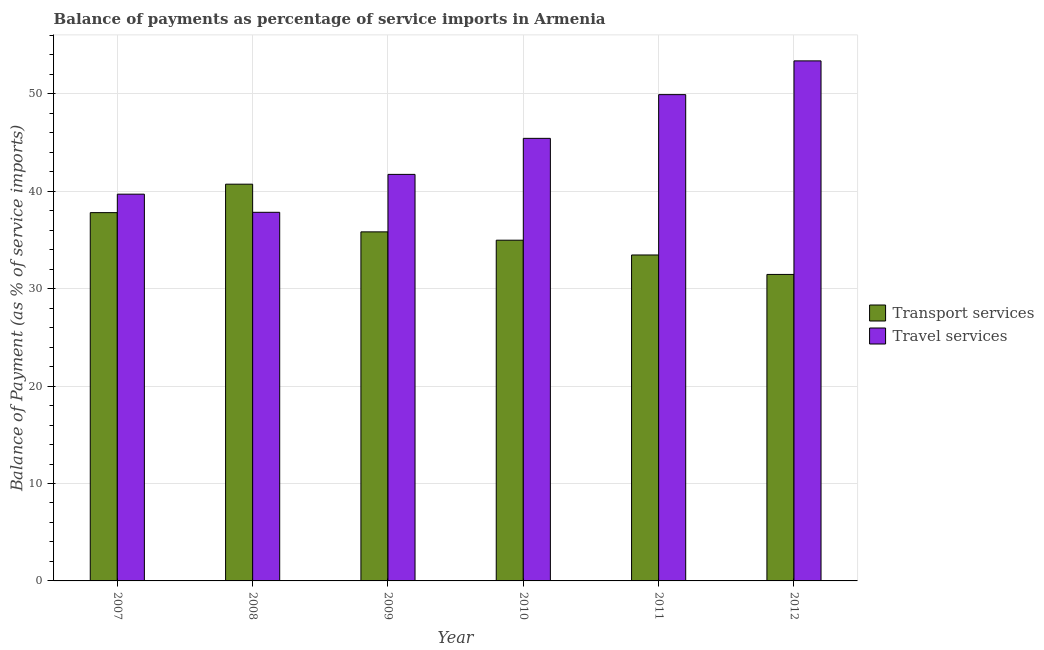How many different coloured bars are there?
Your answer should be very brief. 2. How many groups of bars are there?
Offer a very short reply. 6. How many bars are there on the 3rd tick from the left?
Offer a very short reply. 2. How many bars are there on the 2nd tick from the right?
Give a very brief answer. 2. What is the label of the 5th group of bars from the left?
Keep it short and to the point. 2011. In how many cases, is the number of bars for a given year not equal to the number of legend labels?
Your response must be concise. 0. What is the balance of payments of travel services in 2010?
Offer a very short reply. 45.43. Across all years, what is the maximum balance of payments of transport services?
Offer a terse response. 40.72. Across all years, what is the minimum balance of payments of travel services?
Give a very brief answer. 37.84. In which year was the balance of payments of travel services maximum?
Your response must be concise. 2012. What is the total balance of payments of transport services in the graph?
Your answer should be very brief. 214.24. What is the difference between the balance of payments of transport services in 2008 and that in 2012?
Make the answer very short. 9.26. What is the difference between the balance of payments of travel services in 2010 and the balance of payments of transport services in 2009?
Your answer should be very brief. 3.7. What is the average balance of payments of transport services per year?
Give a very brief answer. 35.71. In the year 2007, what is the difference between the balance of payments of travel services and balance of payments of transport services?
Your answer should be compact. 0. What is the ratio of the balance of payments of transport services in 2011 to that in 2012?
Ensure brevity in your answer.  1.06. Is the balance of payments of transport services in 2008 less than that in 2012?
Your answer should be very brief. No. What is the difference between the highest and the second highest balance of payments of transport services?
Your response must be concise. 2.92. What is the difference between the highest and the lowest balance of payments of travel services?
Keep it short and to the point. 15.54. In how many years, is the balance of payments of transport services greater than the average balance of payments of transport services taken over all years?
Ensure brevity in your answer.  3. Is the sum of the balance of payments of transport services in 2007 and 2010 greater than the maximum balance of payments of travel services across all years?
Provide a short and direct response. Yes. What does the 2nd bar from the left in 2009 represents?
Make the answer very short. Travel services. What does the 2nd bar from the right in 2012 represents?
Give a very brief answer. Transport services. How many bars are there?
Make the answer very short. 12. Are all the bars in the graph horizontal?
Provide a succinct answer. No. What is the difference between two consecutive major ticks on the Y-axis?
Ensure brevity in your answer.  10. Are the values on the major ticks of Y-axis written in scientific E-notation?
Your response must be concise. No. Does the graph contain any zero values?
Give a very brief answer. No. Does the graph contain grids?
Your answer should be compact. Yes. Where does the legend appear in the graph?
Keep it short and to the point. Center right. How many legend labels are there?
Your answer should be compact. 2. How are the legend labels stacked?
Your answer should be compact. Vertical. What is the title of the graph?
Ensure brevity in your answer.  Balance of payments as percentage of service imports in Armenia. Does "US$" appear as one of the legend labels in the graph?
Keep it short and to the point. No. What is the label or title of the X-axis?
Your answer should be compact. Year. What is the label or title of the Y-axis?
Offer a terse response. Balance of Payment (as % of service imports). What is the Balance of Payment (as % of service imports) in Transport services in 2007?
Offer a very short reply. 37.8. What is the Balance of Payment (as % of service imports) in Travel services in 2007?
Provide a short and direct response. 39.7. What is the Balance of Payment (as % of service imports) in Transport services in 2008?
Your answer should be very brief. 40.72. What is the Balance of Payment (as % of service imports) of Travel services in 2008?
Provide a short and direct response. 37.84. What is the Balance of Payment (as % of service imports) of Transport services in 2009?
Give a very brief answer. 35.83. What is the Balance of Payment (as % of service imports) in Travel services in 2009?
Your answer should be compact. 41.73. What is the Balance of Payment (as % of service imports) in Transport services in 2010?
Offer a very short reply. 34.97. What is the Balance of Payment (as % of service imports) of Travel services in 2010?
Provide a short and direct response. 45.43. What is the Balance of Payment (as % of service imports) of Transport services in 2011?
Your answer should be very brief. 33.46. What is the Balance of Payment (as % of service imports) of Travel services in 2011?
Keep it short and to the point. 49.91. What is the Balance of Payment (as % of service imports) in Transport services in 2012?
Make the answer very short. 31.46. What is the Balance of Payment (as % of service imports) of Travel services in 2012?
Provide a short and direct response. 53.38. Across all years, what is the maximum Balance of Payment (as % of service imports) in Transport services?
Make the answer very short. 40.72. Across all years, what is the maximum Balance of Payment (as % of service imports) of Travel services?
Make the answer very short. 53.38. Across all years, what is the minimum Balance of Payment (as % of service imports) in Transport services?
Your answer should be very brief. 31.46. Across all years, what is the minimum Balance of Payment (as % of service imports) in Travel services?
Your answer should be compact. 37.84. What is the total Balance of Payment (as % of service imports) of Transport services in the graph?
Give a very brief answer. 214.24. What is the total Balance of Payment (as % of service imports) in Travel services in the graph?
Provide a succinct answer. 267.98. What is the difference between the Balance of Payment (as % of service imports) in Transport services in 2007 and that in 2008?
Offer a very short reply. -2.92. What is the difference between the Balance of Payment (as % of service imports) in Travel services in 2007 and that in 2008?
Provide a succinct answer. 1.86. What is the difference between the Balance of Payment (as % of service imports) in Transport services in 2007 and that in 2009?
Provide a short and direct response. 1.97. What is the difference between the Balance of Payment (as % of service imports) in Travel services in 2007 and that in 2009?
Keep it short and to the point. -2.03. What is the difference between the Balance of Payment (as % of service imports) in Transport services in 2007 and that in 2010?
Give a very brief answer. 2.83. What is the difference between the Balance of Payment (as % of service imports) in Travel services in 2007 and that in 2010?
Your answer should be very brief. -5.73. What is the difference between the Balance of Payment (as % of service imports) of Transport services in 2007 and that in 2011?
Offer a terse response. 4.35. What is the difference between the Balance of Payment (as % of service imports) of Travel services in 2007 and that in 2011?
Your answer should be compact. -10.22. What is the difference between the Balance of Payment (as % of service imports) of Transport services in 2007 and that in 2012?
Offer a very short reply. 6.34. What is the difference between the Balance of Payment (as % of service imports) of Travel services in 2007 and that in 2012?
Your answer should be very brief. -13.68. What is the difference between the Balance of Payment (as % of service imports) in Transport services in 2008 and that in 2009?
Your response must be concise. 4.89. What is the difference between the Balance of Payment (as % of service imports) in Travel services in 2008 and that in 2009?
Your answer should be very brief. -3.89. What is the difference between the Balance of Payment (as % of service imports) in Transport services in 2008 and that in 2010?
Give a very brief answer. 5.75. What is the difference between the Balance of Payment (as % of service imports) of Travel services in 2008 and that in 2010?
Make the answer very short. -7.59. What is the difference between the Balance of Payment (as % of service imports) of Transport services in 2008 and that in 2011?
Provide a succinct answer. 7.27. What is the difference between the Balance of Payment (as % of service imports) of Travel services in 2008 and that in 2011?
Your answer should be compact. -12.08. What is the difference between the Balance of Payment (as % of service imports) in Transport services in 2008 and that in 2012?
Provide a short and direct response. 9.26. What is the difference between the Balance of Payment (as % of service imports) of Travel services in 2008 and that in 2012?
Offer a terse response. -15.54. What is the difference between the Balance of Payment (as % of service imports) in Transport services in 2009 and that in 2010?
Offer a very short reply. 0.86. What is the difference between the Balance of Payment (as % of service imports) in Travel services in 2009 and that in 2010?
Provide a short and direct response. -3.7. What is the difference between the Balance of Payment (as % of service imports) in Transport services in 2009 and that in 2011?
Provide a short and direct response. 2.37. What is the difference between the Balance of Payment (as % of service imports) of Travel services in 2009 and that in 2011?
Your response must be concise. -8.19. What is the difference between the Balance of Payment (as % of service imports) in Transport services in 2009 and that in 2012?
Make the answer very short. 4.37. What is the difference between the Balance of Payment (as % of service imports) of Travel services in 2009 and that in 2012?
Keep it short and to the point. -11.65. What is the difference between the Balance of Payment (as % of service imports) in Transport services in 2010 and that in 2011?
Your answer should be compact. 1.52. What is the difference between the Balance of Payment (as % of service imports) in Travel services in 2010 and that in 2011?
Offer a very short reply. -4.49. What is the difference between the Balance of Payment (as % of service imports) in Transport services in 2010 and that in 2012?
Your response must be concise. 3.51. What is the difference between the Balance of Payment (as % of service imports) in Travel services in 2010 and that in 2012?
Make the answer very short. -7.95. What is the difference between the Balance of Payment (as % of service imports) in Transport services in 2011 and that in 2012?
Provide a short and direct response. 2. What is the difference between the Balance of Payment (as % of service imports) of Travel services in 2011 and that in 2012?
Offer a terse response. -3.46. What is the difference between the Balance of Payment (as % of service imports) of Transport services in 2007 and the Balance of Payment (as % of service imports) of Travel services in 2008?
Your answer should be very brief. -0.03. What is the difference between the Balance of Payment (as % of service imports) of Transport services in 2007 and the Balance of Payment (as % of service imports) of Travel services in 2009?
Offer a terse response. -3.93. What is the difference between the Balance of Payment (as % of service imports) in Transport services in 2007 and the Balance of Payment (as % of service imports) in Travel services in 2010?
Your answer should be compact. -7.62. What is the difference between the Balance of Payment (as % of service imports) of Transport services in 2007 and the Balance of Payment (as % of service imports) of Travel services in 2011?
Provide a short and direct response. -12.11. What is the difference between the Balance of Payment (as % of service imports) of Transport services in 2007 and the Balance of Payment (as % of service imports) of Travel services in 2012?
Your response must be concise. -15.58. What is the difference between the Balance of Payment (as % of service imports) of Transport services in 2008 and the Balance of Payment (as % of service imports) of Travel services in 2009?
Provide a succinct answer. -1.01. What is the difference between the Balance of Payment (as % of service imports) of Transport services in 2008 and the Balance of Payment (as % of service imports) of Travel services in 2010?
Your answer should be compact. -4.7. What is the difference between the Balance of Payment (as % of service imports) in Transport services in 2008 and the Balance of Payment (as % of service imports) in Travel services in 2011?
Give a very brief answer. -9.19. What is the difference between the Balance of Payment (as % of service imports) of Transport services in 2008 and the Balance of Payment (as % of service imports) of Travel services in 2012?
Offer a terse response. -12.66. What is the difference between the Balance of Payment (as % of service imports) in Transport services in 2009 and the Balance of Payment (as % of service imports) in Travel services in 2010?
Ensure brevity in your answer.  -9.6. What is the difference between the Balance of Payment (as % of service imports) in Transport services in 2009 and the Balance of Payment (as % of service imports) in Travel services in 2011?
Offer a very short reply. -14.09. What is the difference between the Balance of Payment (as % of service imports) of Transport services in 2009 and the Balance of Payment (as % of service imports) of Travel services in 2012?
Make the answer very short. -17.55. What is the difference between the Balance of Payment (as % of service imports) of Transport services in 2010 and the Balance of Payment (as % of service imports) of Travel services in 2011?
Provide a succinct answer. -14.94. What is the difference between the Balance of Payment (as % of service imports) of Transport services in 2010 and the Balance of Payment (as % of service imports) of Travel services in 2012?
Give a very brief answer. -18.41. What is the difference between the Balance of Payment (as % of service imports) of Transport services in 2011 and the Balance of Payment (as % of service imports) of Travel services in 2012?
Your answer should be very brief. -19.92. What is the average Balance of Payment (as % of service imports) of Transport services per year?
Give a very brief answer. 35.71. What is the average Balance of Payment (as % of service imports) of Travel services per year?
Offer a very short reply. 44.66. In the year 2007, what is the difference between the Balance of Payment (as % of service imports) in Transport services and Balance of Payment (as % of service imports) in Travel services?
Offer a very short reply. -1.89. In the year 2008, what is the difference between the Balance of Payment (as % of service imports) of Transport services and Balance of Payment (as % of service imports) of Travel services?
Provide a short and direct response. 2.89. In the year 2009, what is the difference between the Balance of Payment (as % of service imports) in Transport services and Balance of Payment (as % of service imports) in Travel services?
Your answer should be very brief. -5.9. In the year 2010, what is the difference between the Balance of Payment (as % of service imports) in Transport services and Balance of Payment (as % of service imports) in Travel services?
Give a very brief answer. -10.45. In the year 2011, what is the difference between the Balance of Payment (as % of service imports) in Transport services and Balance of Payment (as % of service imports) in Travel services?
Keep it short and to the point. -16.46. In the year 2012, what is the difference between the Balance of Payment (as % of service imports) in Transport services and Balance of Payment (as % of service imports) in Travel services?
Your answer should be very brief. -21.92. What is the ratio of the Balance of Payment (as % of service imports) of Transport services in 2007 to that in 2008?
Make the answer very short. 0.93. What is the ratio of the Balance of Payment (as % of service imports) in Travel services in 2007 to that in 2008?
Make the answer very short. 1.05. What is the ratio of the Balance of Payment (as % of service imports) of Transport services in 2007 to that in 2009?
Provide a short and direct response. 1.06. What is the ratio of the Balance of Payment (as % of service imports) in Travel services in 2007 to that in 2009?
Give a very brief answer. 0.95. What is the ratio of the Balance of Payment (as % of service imports) of Transport services in 2007 to that in 2010?
Offer a terse response. 1.08. What is the ratio of the Balance of Payment (as % of service imports) in Travel services in 2007 to that in 2010?
Keep it short and to the point. 0.87. What is the ratio of the Balance of Payment (as % of service imports) of Transport services in 2007 to that in 2011?
Ensure brevity in your answer.  1.13. What is the ratio of the Balance of Payment (as % of service imports) in Travel services in 2007 to that in 2011?
Your answer should be compact. 0.8. What is the ratio of the Balance of Payment (as % of service imports) of Transport services in 2007 to that in 2012?
Keep it short and to the point. 1.2. What is the ratio of the Balance of Payment (as % of service imports) in Travel services in 2007 to that in 2012?
Give a very brief answer. 0.74. What is the ratio of the Balance of Payment (as % of service imports) in Transport services in 2008 to that in 2009?
Your response must be concise. 1.14. What is the ratio of the Balance of Payment (as % of service imports) in Travel services in 2008 to that in 2009?
Make the answer very short. 0.91. What is the ratio of the Balance of Payment (as % of service imports) in Transport services in 2008 to that in 2010?
Make the answer very short. 1.16. What is the ratio of the Balance of Payment (as % of service imports) in Travel services in 2008 to that in 2010?
Ensure brevity in your answer.  0.83. What is the ratio of the Balance of Payment (as % of service imports) in Transport services in 2008 to that in 2011?
Your answer should be compact. 1.22. What is the ratio of the Balance of Payment (as % of service imports) of Travel services in 2008 to that in 2011?
Your answer should be very brief. 0.76. What is the ratio of the Balance of Payment (as % of service imports) in Transport services in 2008 to that in 2012?
Make the answer very short. 1.29. What is the ratio of the Balance of Payment (as % of service imports) in Travel services in 2008 to that in 2012?
Give a very brief answer. 0.71. What is the ratio of the Balance of Payment (as % of service imports) in Transport services in 2009 to that in 2010?
Keep it short and to the point. 1.02. What is the ratio of the Balance of Payment (as % of service imports) in Travel services in 2009 to that in 2010?
Provide a succinct answer. 0.92. What is the ratio of the Balance of Payment (as % of service imports) of Transport services in 2009 to that in 2011?
Provide a succinct answer. 1.07. What is the ratio of the Balance of Payment (as % of service imports) in Travel services in 2009 to that in 2011?
Offer a terse response. 0.84. What is the ratio of the Balance of Payment (as % of service imports) in Transport services in 2009 to that in 2012?
Offer a terse response. 1.14. What is the ratio of the Balance of Payment (as % of service imports) in Travel services in 2009 to that in 2012?
Keep it short and to the point. 0.78. What is the ratio of the Balance of Payment (as % of service imports) of Transport services in 2010 to that in 2011?
Ensure brevity in your answer.  1.05. What is the ratio of the Balance of Payment (as % of service imports) in Travel services in 2010 to that in 2011?
Ensure brevity in your answer.  0.91. What is the ratio of the Balance of Payment (as % of service imports) in Transport services in 2010 to that in 2012?
Offer a terse response. 1.11. What is the ratio of the Balance of Payment (as % of service imports) in Travel services in 2010 to that in 2012?
Make the answer very short. 0.85. What is the ratio of the Balance of Payment (as % of service imports) of Transport services in 2011 to that in 2012?
Your answer should be compact. 1.06. What is the ratio of the Balance of Payment (as % of service imports) of Travel services in 2011 to that in 2012?
Keep it short and to the point. 0.94. What is the difference between the highest and the second highest Balance of Payment (as % of service imports) of Transport services?
Keep it short and to the point. 2.92. What is the difference between the highest and the second highest Balance of Payment (as % of service imports) of Travel services?
Offer a terse response. 3.46. What is the difference between the highest and the lowest Balance of Payment (as % of service imports) of Transport services?
Your answer should be very brief. 9.26. What is the difference between the highest and the lowest Balance of Payment (as % of service imports) of Travel services?
Your response must be concise. 15.54. 